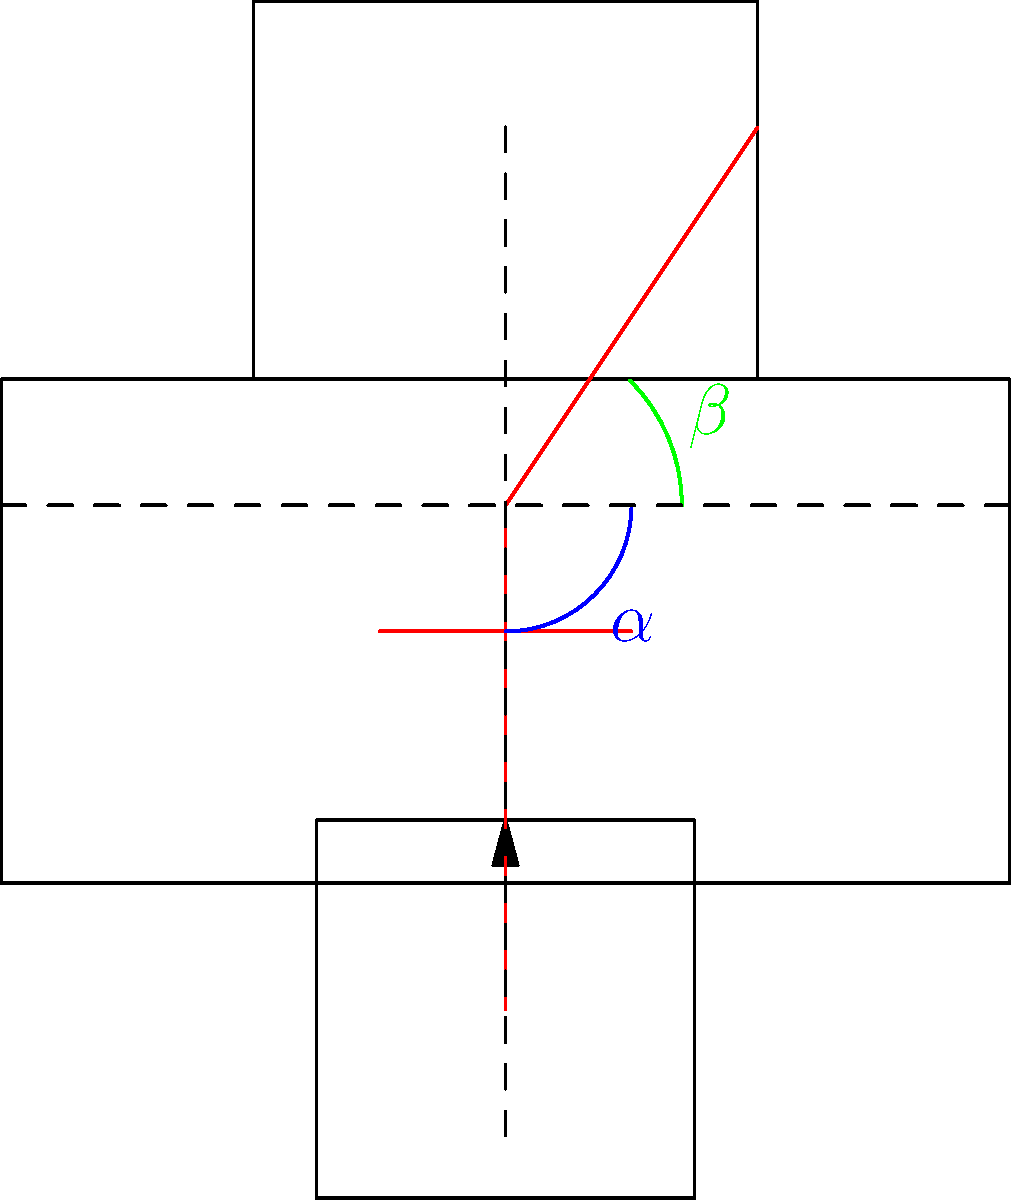As a sympathetic employer, you notice that one of your dedicated employees is experiencing discomfort while working at their desk. Upon observing their posture, you see that their upper arms form an angle $\alpha$ with their torso, and their gaze forms an angle $\beta$ with the horizontal when looking at the center of their monitor. What should the ideal values of $\alpha$ and $\beta$ be for optimal ergonomics, and what adjustments would you suggest to help your employee achieve better posture? To determine the ideal ergonomic setup and suggest improvements, let's consider the following steps:

1. Upper arm angle ($\alpha$):
   - The ideal angle between the upper arm and torso should be approximately 90 degrees (vertical).
   - This allows for a relaxed shoulder position and reduces strain on the neck and upper back.

2. Gaze angle ($\beta$):
   - The ideal gaze angle when looking at the center of the monitor should be between 15 to 20 degrees below horizontal.
   - This helps maintain a neutral neck position and reduces eye strain.

3. Adjustments to achieve optimal posture:
   a. Chair height:
      - Adjust the chair height so that the employee's feet are flat on the floor and thighs are parallel to the ground.
      - This will help achieve the correct upper arm angle ($\alpha$).

   b. Monitor height:
      - Adjust the monitor height so that the top of the screen is at or slightly below eye level.
      - This will help achieve the correct gaze angle ($\beta$).

   c. Keyboard and mouse position:
      - Ensure the keyboard and mouse are positioned so that the elbows remain close to the body and form a 90-degree angle.

   d. Lumbar support:
      - Provide a chair with adequate lumbar support to maintain the natural curve of the lower back.

   e. Distance from screen:
      - Position the monitor about an arm's length away from the employee (approximately 20-30 inches).

By implementing these adjustments, you can help your employee achieve better posture and reduce the risk of discomfort or injury associated with prolonged desk work.
Answer: $\alpha = 90°$, $\beta = 15-20°$ below horizontal. Adjust chair height, monitor height, keyboard/mouse position, provide lumbar support, and set correct screen distance. 